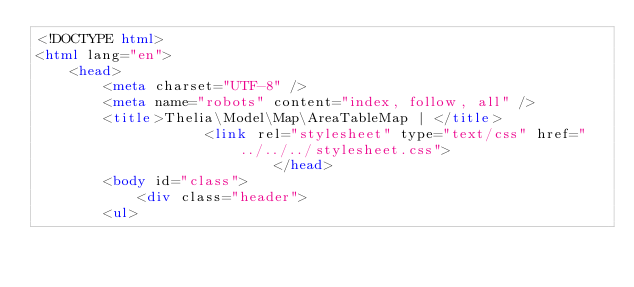<code> <loc_0><loc_0><loc_500><loc_500><_HTML_><!DOCTYPE html>
<html lang="en">
    <head>
        <meta charset="UTF-8" />
        <meta name="robots" content="index, follow, all" />
        <title>Thelia\Model\Map\AreaTableMap | </title>
                    <link rel="stylesheet" type="text/css" href="../../../stylesheet.css">
                            </head>
        <body id="class">
            <div class="header">
        <ul></code> 